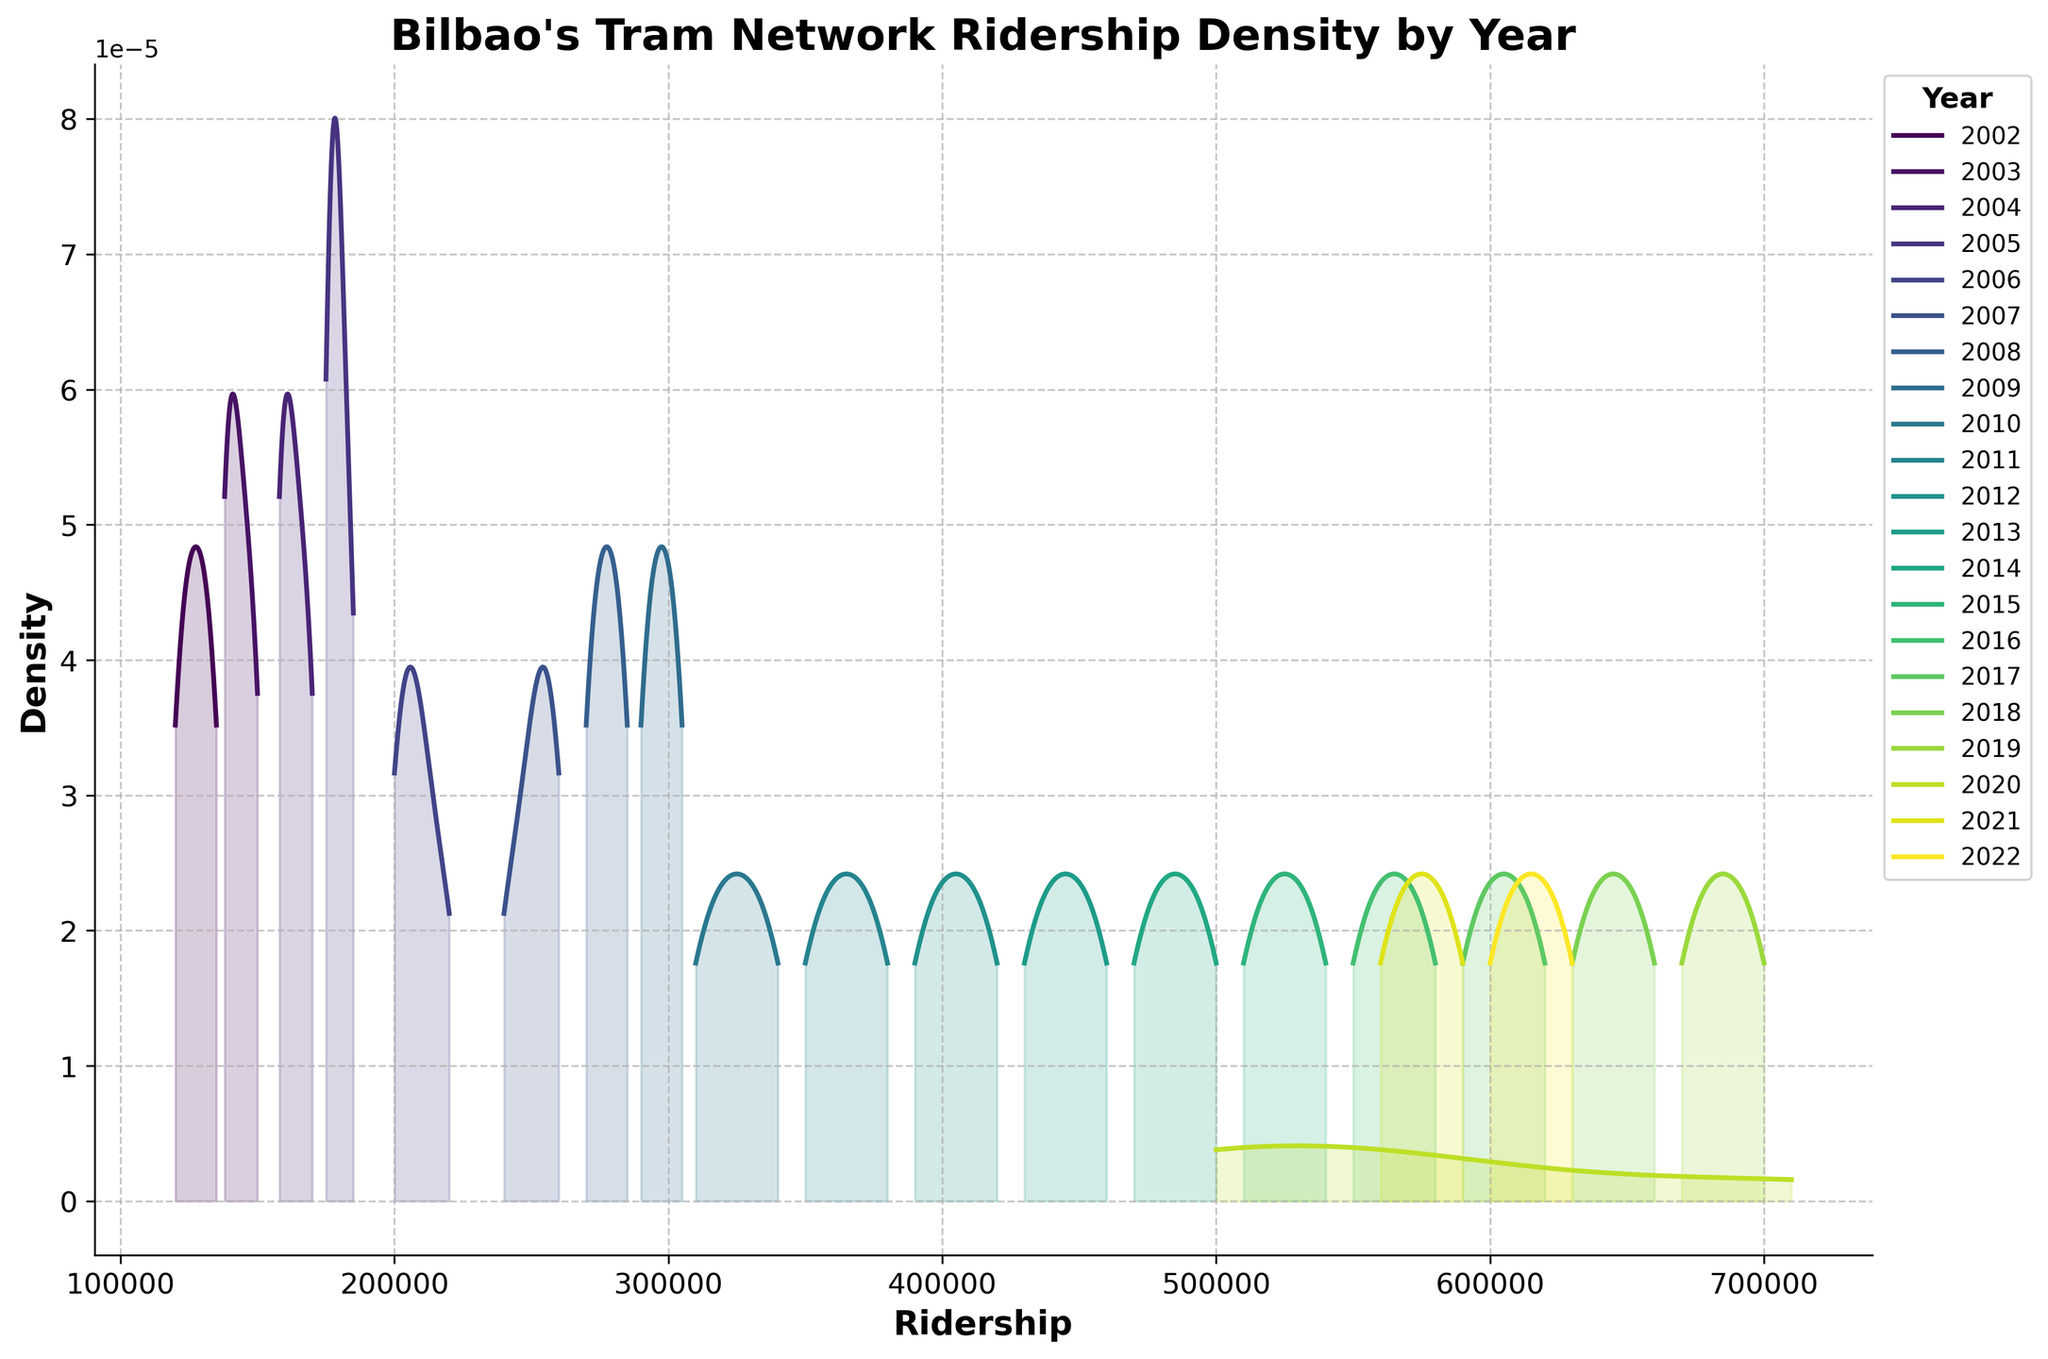what is the title of the plot? The title of the plot is found at the top of the figure. From the existing data provided in the code, the title is "Bilbao's Tram Network Ridership Density by Year"
Answer: Bilbao's Tram Network Ridership Density by Year How many unique years are represented in the plot? To find the number of unique years, look at the legend which lists each year separately. Based on the data and the color legend, there are 21 unique years.
Answer: 21 Which year has the highest peak density? Examine the density curves to identify the one that reaches the highest point on the y-axis. The year with the curve that peaks highest is 2019.
Answer: 2019 During which year did the ridership density significantly drop and then recover? By inspecting the density curves, we notice a significant drop and later a recovery in 2020 due to the COVID-19 pandemic.
Answer: 2020 What's the ridership range in the year 2002? The range can be found by identifying the minimum and maximum ridership values represented in the 2002 density curve. By examining closely, we see that the ridership ranges from around 120,000 to 135,000.
Answer: 120,000 to 135,000 Which year had the most consistent ridership values? Look for the density curve that is the narrowest and tallest, indicating consistency in ridership values. The year 2006 shows the most consistent ridership.
Answer: 2006 Compare the ridership between 2020 and 2021. Which year had a wider range of values? By comparing the width of the density curves for the years 2020 and 2021, we see that 2020 had a wider range, indicating more variability in ridership due to the pandemic.
Answer: 2020 In which quarter of 2019 did ridership reach its highest value? Though the exact quarters are not shown on the density plot, examining the general trend indicates that the Q4 usually tends to have the highest ridership values.
Answer: Q4 